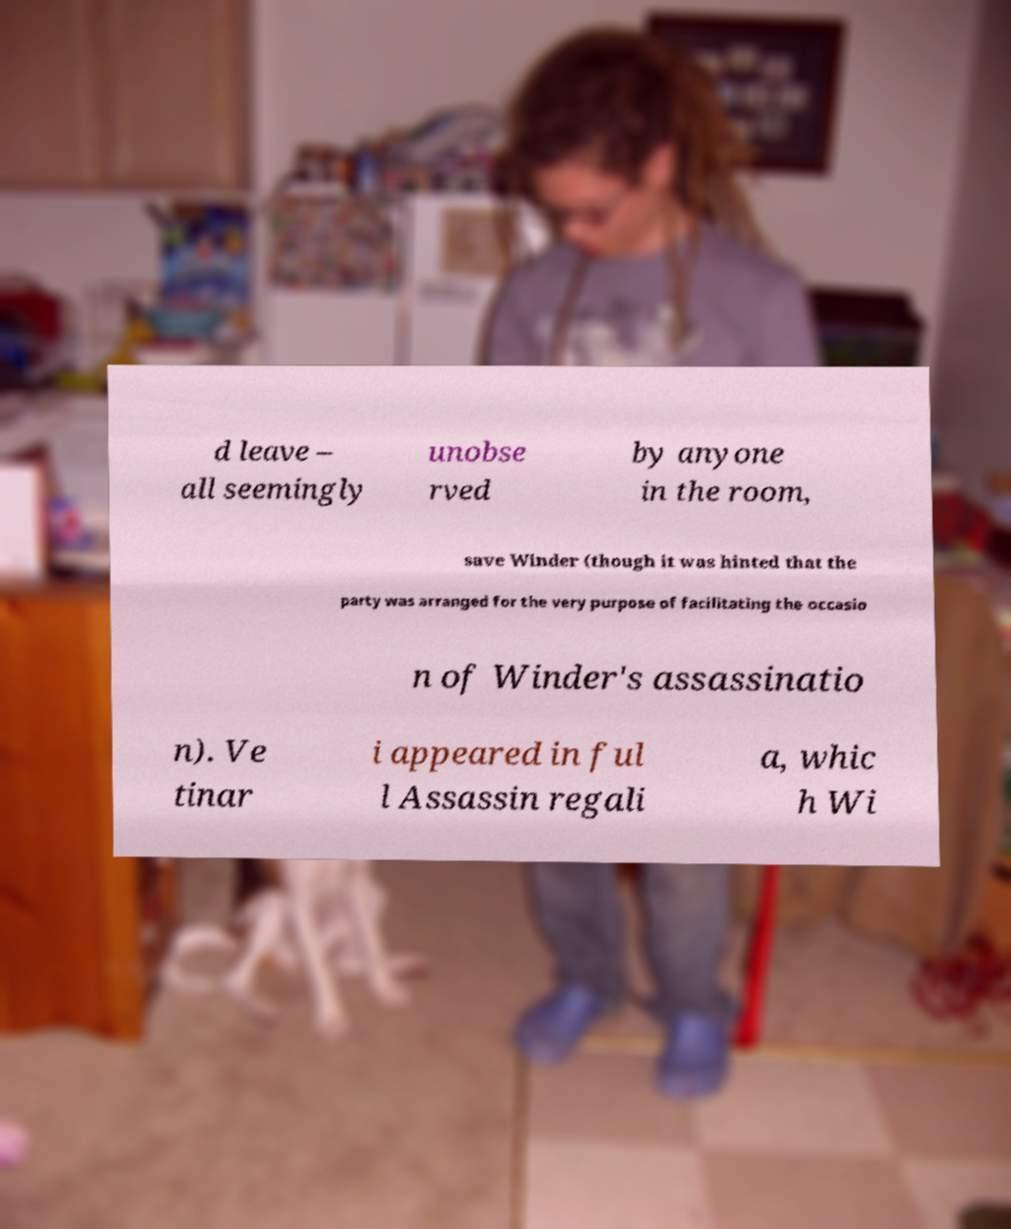For documentation purposes, I need the text within this image transcribed. Could you provide that? d leave – all seemingly unobse rved by anyone in the room, save Winder (though it was hinted that the party was arranged for the very purpose of facilitating the occasio n of Winder's assassinatio n). Ve tinar i appeared in ful l Assassin regali a, whic h Wi 